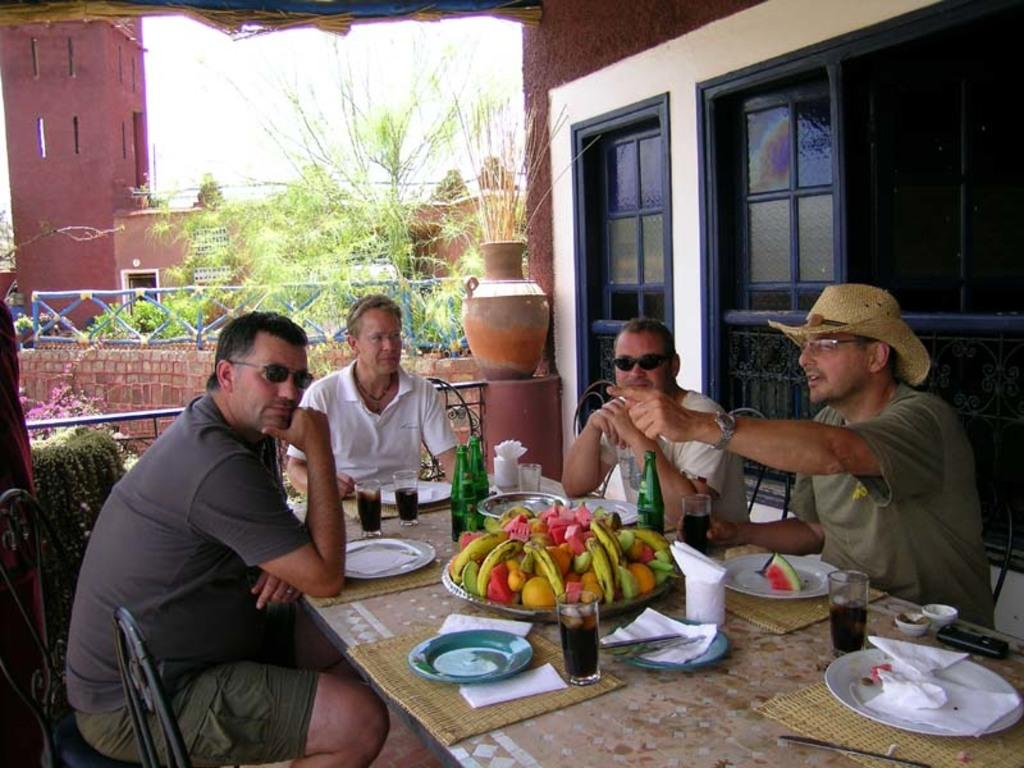How many people are sitting in the image? There are four people sitting on chairs in the image. What objects can be seen on the table? There is a plate, a glass, a tissue, fruits, and a bottle on the table. What is visible in the background of the image? There is a building and plants visible in the background. What type of beetle can be seen crawling on the fruits in the image? There are no beetles present in the image; it only features fruits on the table. What activity are the people engaged in while sitting on the chairs? The provided facts do not specify any particular activity that the people are engaged in while sitting on the chairs. 